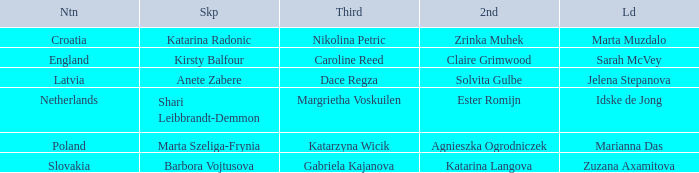Parse the full table. {'header': ['Ntn', 'Skp', 'Third', '2nd', 'Ld'], 'rows': [['Croatia', 'Katarina Radonic', 'Nikolina Petric', 'Zrinka Muhek', 'Marta Muzdalo'], ['England', 'Kirsty Balfour', 'Caroline Reed', 'Claire Grimwood', 'Sarah McVey'], ['Latvia', 'Anete Zabere', 'Dace Regza', 'Solvita Gulbe', 'Jelena Stepanova'], ['Netherlands', 'Shari Leibbrandt-Demmon', 'Margrietha Voskuilen', 'Ester Romijn', 'Idske de Jong'], ['Poland', 'Marta Szeliga-Frynia', 'Katarzyna Wicik', 'Agnieszka Ogrodniczek', 'Marianna Das'], ['Slovakia', 'Barbora Vojtusova', 'Gabriela Kajanova', 'Katarina Langova', 'Zuzana Axamitova']]} What is the name of the second who has Caroline Reed as third? Claire Grimwood. 